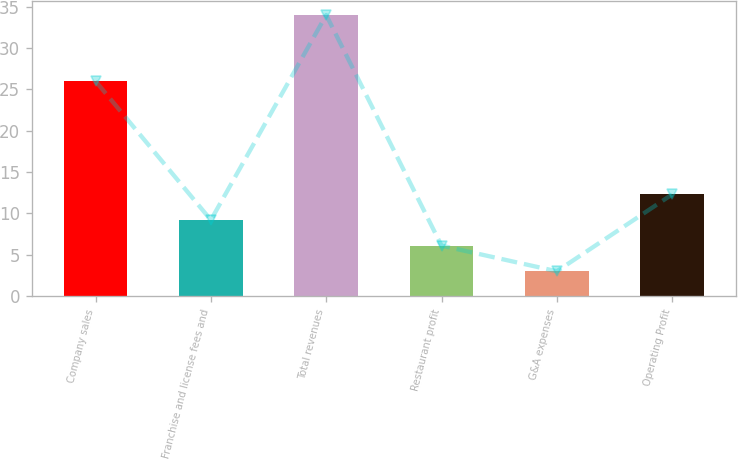<chart> <loc_0><loc_0><loc_500><loc_500><bar_chart><fcel>Company sales<fcel>Franchise and license fees and<fcel>Total revenues<fcel>Restaurant profit<fcel>G&A expenses<fcel>Operating Profit<nl><fcel>26<fcel>9.2<fcel>34<fcel>6.1<fcel>3<fcel>12.3<nl></chart> 